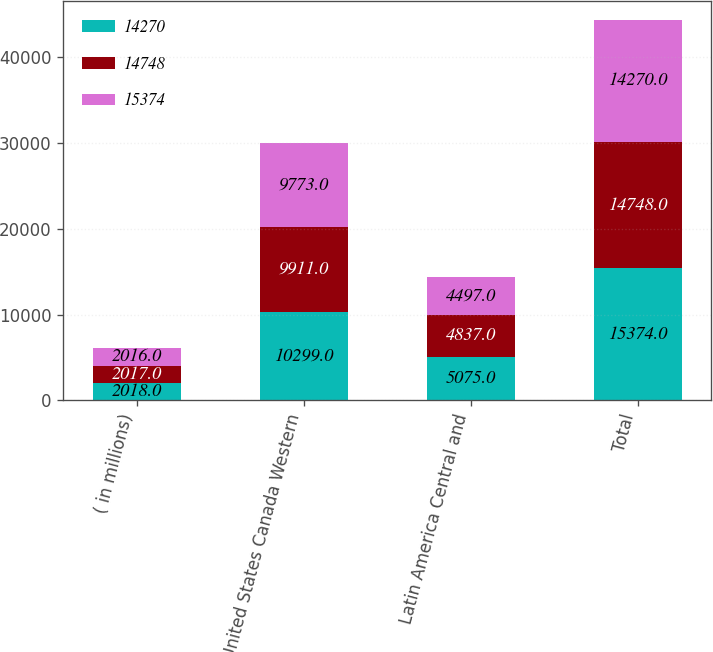Convert chart to OTSL. <chart><loc_0><loc_0><loc_500><loc_500><stacked_bar_chart><ecel><fcel>( in millions)<fcel>United States Canada Western<fcel>Latin America Central and<fcel>Total<nl><fcel>14270<fcel>2018<fcel>10299<fcel>5075<fcel>15374<nl><fcel>14748<fcel>2017<fcel>9911<fcel>4837<fcel>14748<nl><fcel>15374<fcel>2016<fcel>9773<fcel>4497<fcel>14270<nl></chart> 